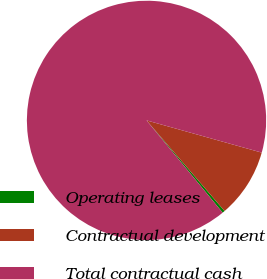<chart> <loc_0><loc_0><loc_500><loc_500><pie_chart><fcel>Operating leases<fcel>Contractual development<fcel>Total contractual cash<nl><fcel>0.34%<fcel>9.34%<fcel>90.31%<nl></chart> 